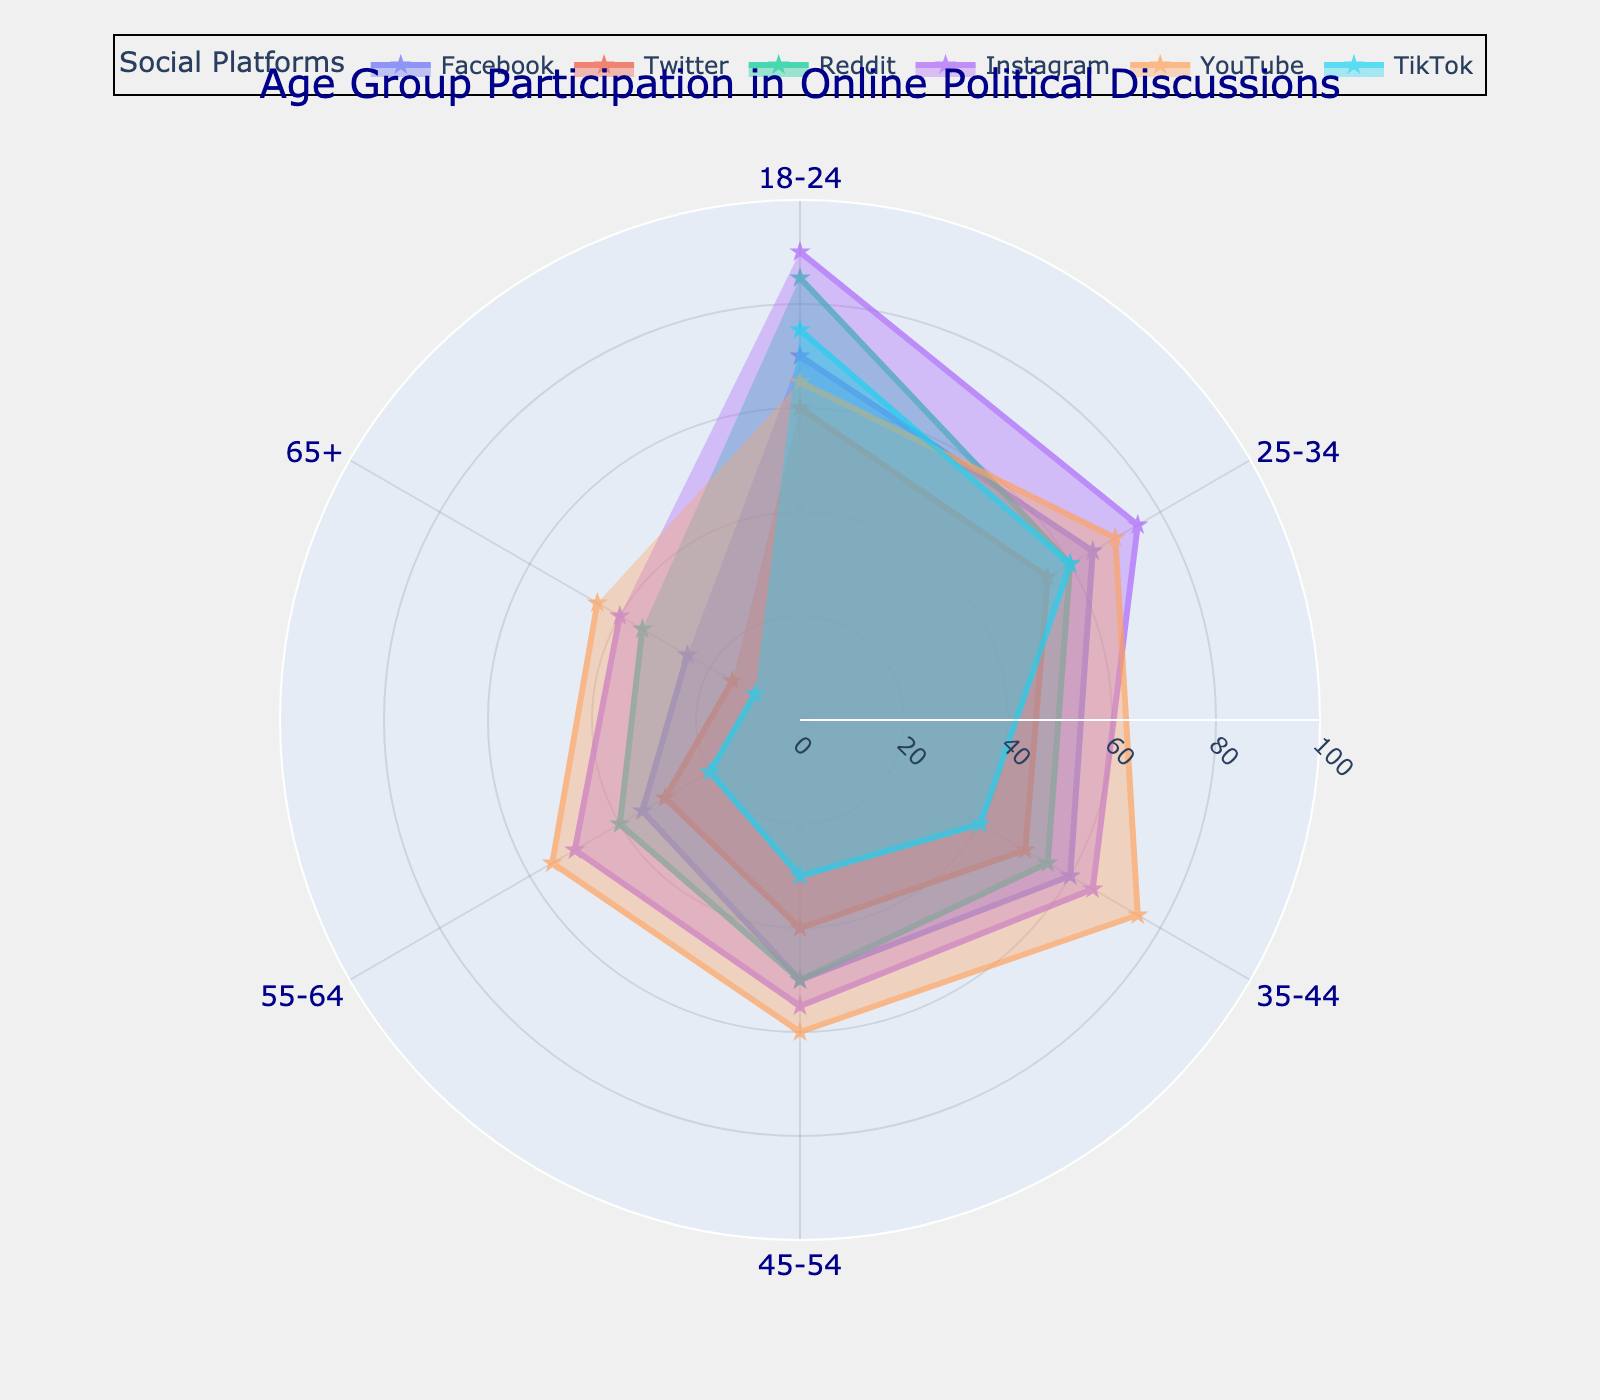what is the title of the radar chart? The title is usually found at the top of the chart. In this case, it reads "Age Group Participation in Online Political Discussions".
Answer: Age Group Participation in Online Political Discussions How many social platforms are represented in the chart? By looking at the legend or the different lines on the radar, you can see six social platforms: Facebook, Twitter, Reddit, Instagram, YouTube, and TikTok.
Answer: Six Which age group has the highest participation in online political discussions on Reddit? Follow the line corresponding to Reddit (typically shown in the legend) and identify the age group at the peak value. This peak occurs at "18-24" with a value of 85.
Answer: 18-24 Which platform has the lowest participation rate for the age group 65+? Find the data point for the age group 65+ on each platform. The lowest value is on TikTok, with a value of 10.
Answer: TikTok What's the average participation rate across all platforms for the 35-44 age group? Sum the participation rates for 35-44 age group across all platforms ((60 + 50 + 55 + 65 + 75 + 40) = 345) and divide by 6 (number of platforms), 345/6.
Answer: 57.5 How much higher is TikTok engagement in the 18-24 group compared to the 45-54 group? Subtract TikTok's participation rate for 45-54 (30) from that of 18-24 (75), 75 - 30.
Answer: 45 Are there any platforms where participation peaks in the 25-34 group? Check if the highest value for any platform occurs in the 25-34 group. None peak in this group; the highest values are in other age groups.
Answer: No Which age group has the lowest participation for Facebook? By looking at the Facebook's line, the lowest value is for the 65+ age group with a value of 25.
Answer: 65+ What is the overall trend of participation in TikTok as the age group increases? Observe TikTok’s value for each age group starting from 18-24 (75) and moving towards 65+ (10). As age increases, participation consistently decreases.
Answer: Decreasing How many age groups have more than 50% participation on YouTube? Identify the age groups where the participation rate is above 50%. The age groups are: 25-34 (70), 35-44 (75), 45-54 (60), and 55-64 (55).
Answer: Four 